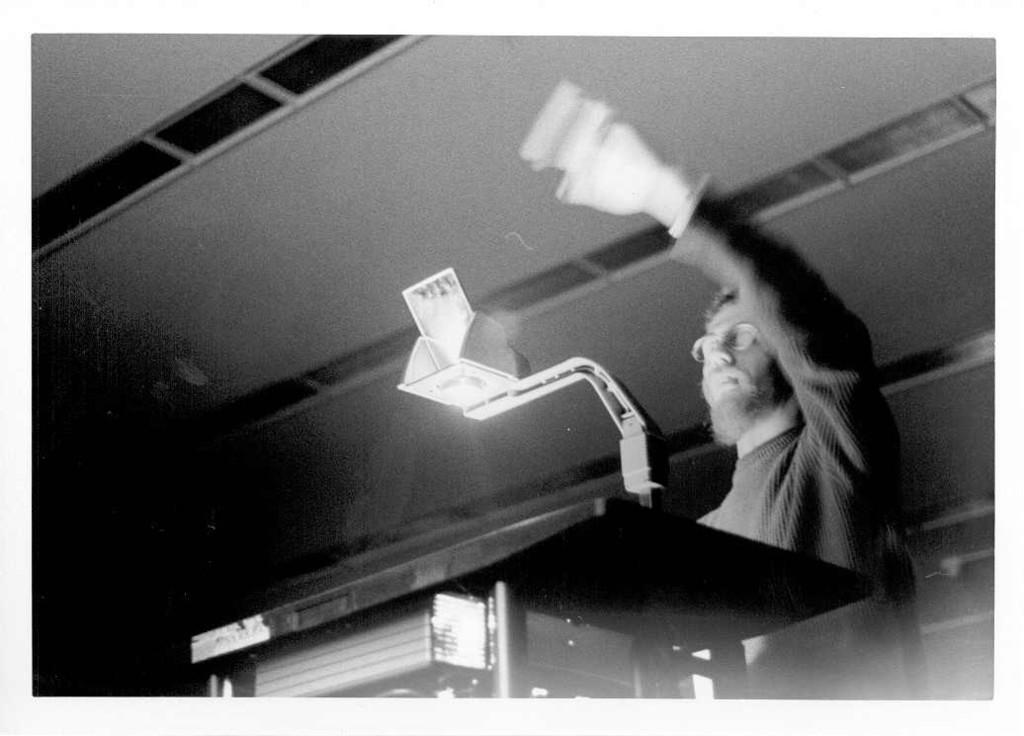Please provide a concise description of this image. In this image I can see on the right side there is a man raising his hand, he is wearing a sweater, spectacles. At the top there is the roof. 